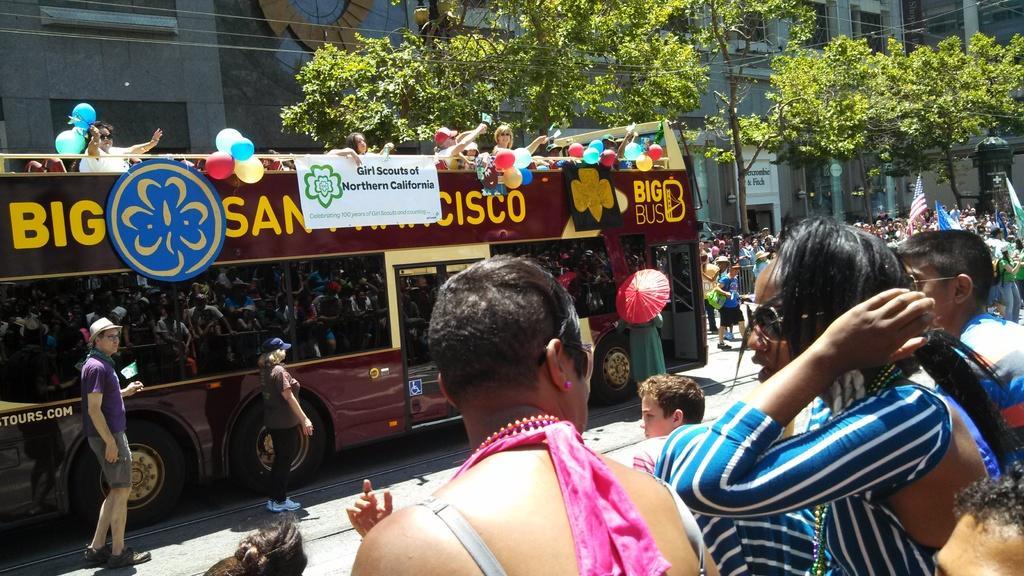How would you summarize this image in a sentence or two? In this picture there is a man who is wearing spectacle. Beside him there is a woman who is wearing blue dress. On the left there are two persons were standing near to the bus. At the top of the bus we can see the persons who are waving their hands, beside them we can see some balloons and banners. On left background we can see many peoples were standing on the road and holding a flag. In the top we can see the electric wires, buildings and trees. 